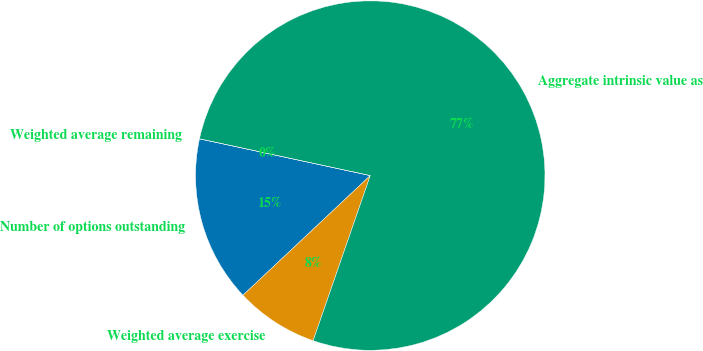<chart> <loc_0><loc_0><loc_500><loc_500><pie_chart><fcel>Number of options outstanding<fcel>Weighted average exercise<fcel>Aggregate intrinsic value as<fcel>Weighted average remaining<nl><fcel>15.38%<fcel>7.69%<fcel>76.92%<fcel>0.0%<nl></chart> 